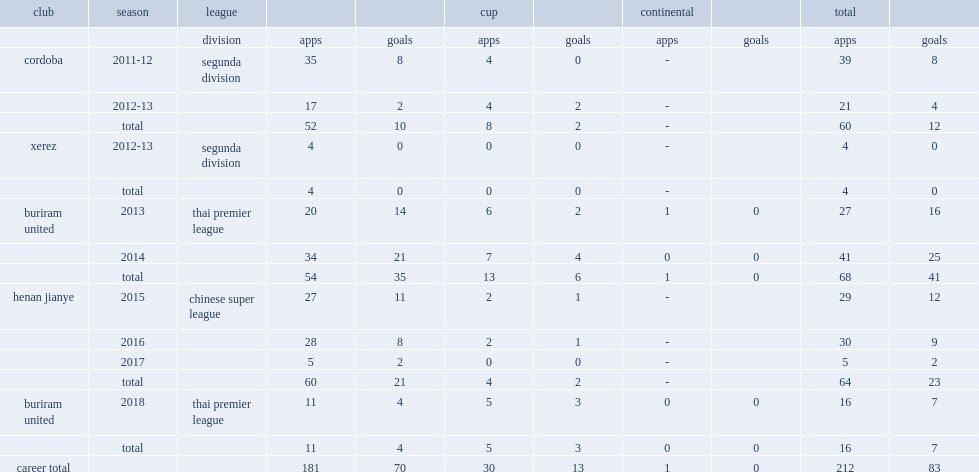In 2013, which league did patino participate for buriram united f.c? Thai premier league. 